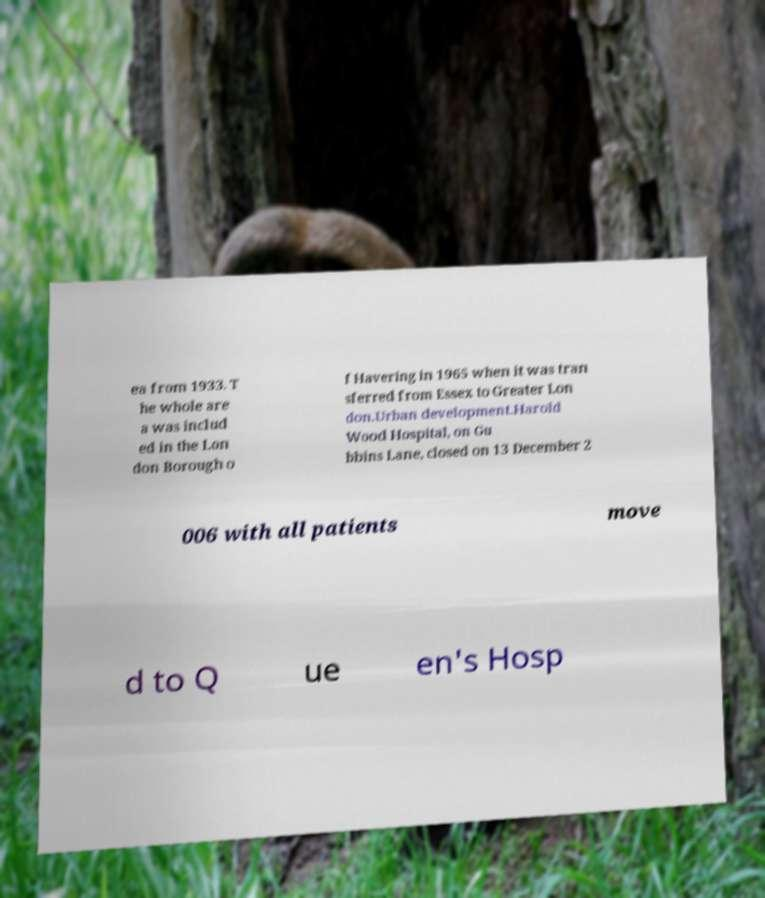Please identify and transcribe the text found in this image. ea from 1933. T he whole are a was includ ed in the Lon don Borough o f Havering in 1965 when it was tran sferred from Essex to Greater Lon don.Urban development.Harold Wood Hospital, on Gu bbins Lane, closed on 13 December 2 006 with all patients move d to Q ue en's Hosp 